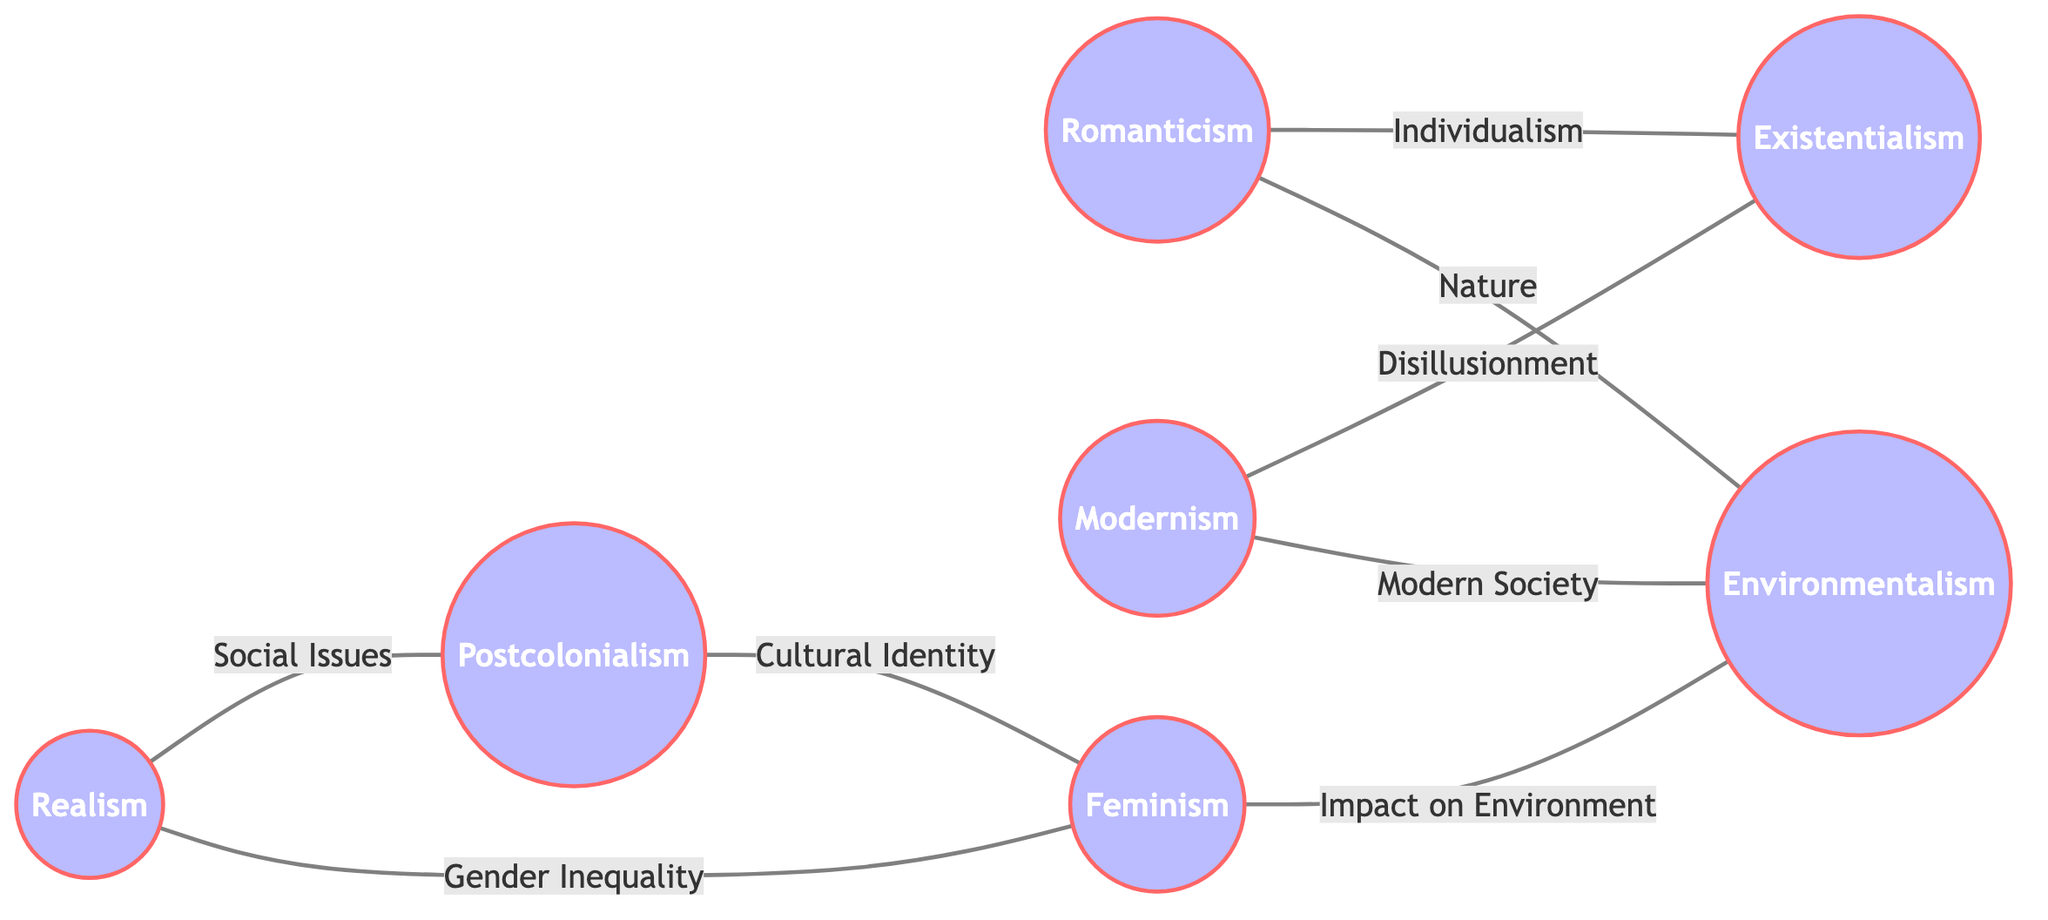What is the total number of nodes in the graph? The graph contains a list of nodes that represent different literary themes. By counting these nodes, we find there are 7 themes listed in total.
Answer: 7 Which themes are directly connected to Romanticism? To find the themes connected to Romanticism, we look at the edges stemming from the node labeled "Romanticism". It connects to Existentialism (via Individualism) and Environmentalism (via Nature).
Answer: Existentialism, Environmentalism What is the theme that connects Realism and Postcolonialism? The edge connecting Realism and Postcolonialism is labeled "Social Issues". By identifying this edge, we can see that it directly links these themes together through that specific connection.
Answer: Social Issues How many edges connect Feminism to other themes? By reviewing the edges that involve the node Feminism, we find two connections: one to Realism (via Gender Inequality) and one to Environmentalism (via Impact on Environment). Therefore, Feminism is connected through 2 edges.
Answer: 2 Which theme has a relationship labeled "Disillusionment"? Examining the edges, we see that the edge between Modernism and Existentialism has the label "Disillusionment". This indicates that Modernism has a direct relationship with Existentialism through this theme.
Answer: Modernism What are the two themes that have a connection through Cultural Identity? The connection through Cultural Identity exists between Postcolonialism and Feminism. By tracing the edge labeled "Cultural Identity", we identify that these two themes share this relationship.
Answer: Postcolonialism, Feminism Which themes share a relationship about the Impact on Environment? The relationship about the Impact on Environment exists between Feminism and Environmentalism. By looking at the connecting edge, we can see this direct relationship outlined in the graph.
Answer: Feminism, Environmentalism What type of relationship exists between Modernism and Environmentalism? The relationship between Modernism and Environmentalism can be traced via the edge labeled "Modern Society". This means that the two themes are connected through societal evolution and its effects.
Answer: Modern Society 